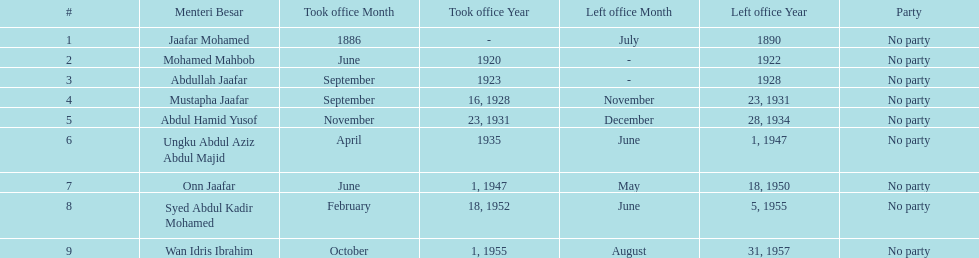Who was the first to take office? Jaafar Mohamed. 